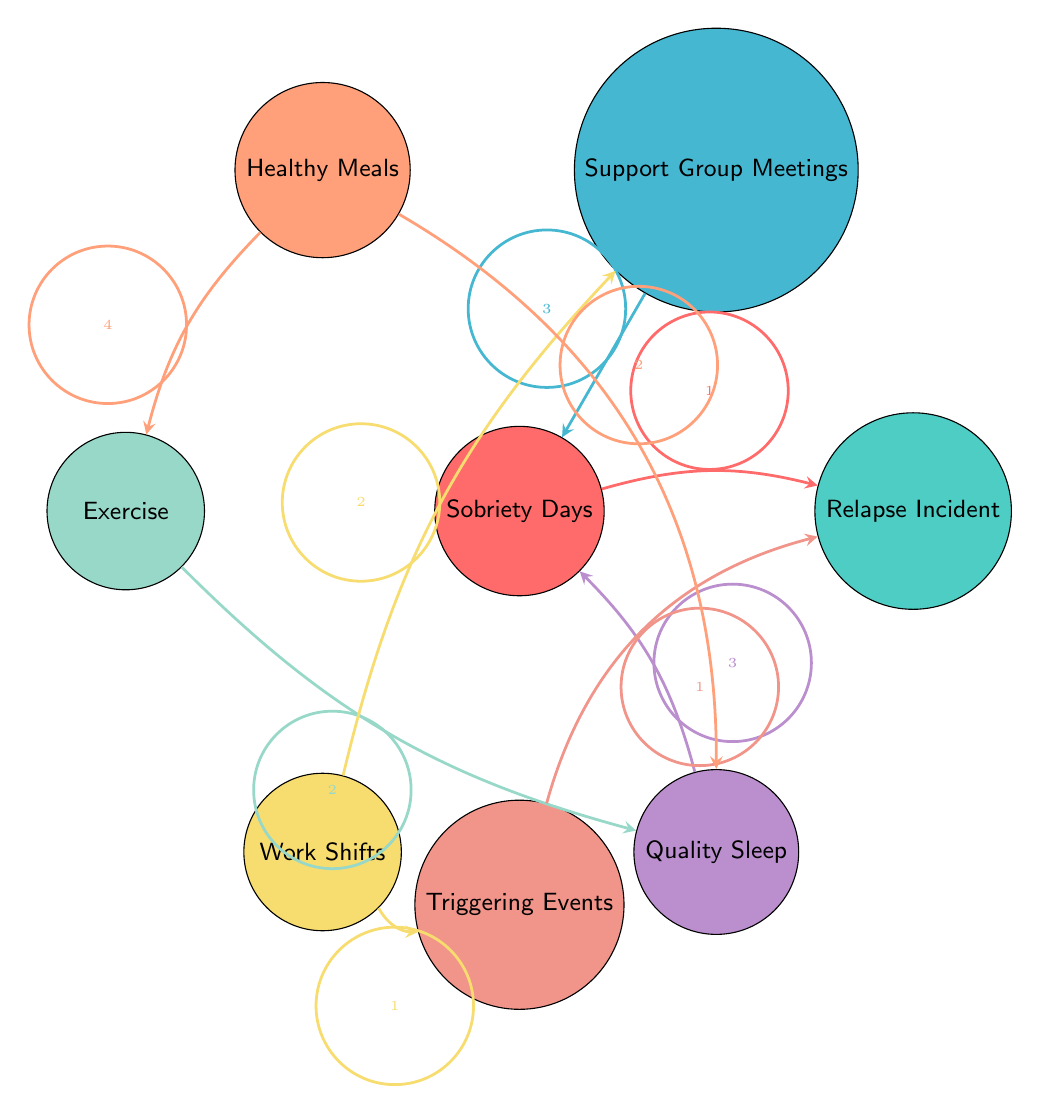What is the value of the link between Sobriety Days and Relapse Incident? The diagram shows a directed link from "Sobriety Days" to "Relapse Incident" with a value of 1. This indicates that there is one recorded incident related to the connection between these two nodes.
Answer: 1 How many nodes are present in the diagram? By counting the circles in the diagram, we identify eight nodes labeled: Sobriety Days, Relapse Incident, Support Group Meetings, Healthy Meals, Exercise, Work Shifts, Quality Sleep, and Triggering Events.
Answer: 8 What is the total value of links associated with Support Group Meetings? The diagram indicates a value of 3 links directed toward "Sobriety Days" and 2 links directed toward "Work Shifts", resulting in a total of 5 connections involving "Support Group Meetings".
Answer: 5 Which node has the highest total outgoing link value? By examining the outgoing links from each node, "Healthy Meals" has an outgoing link to "Exercise" with a value of 4 and to "Quality Sleep" with a value of 2. Therefore, its total outgoing links value of 6 is the highest.
Answer: Healthy Meals What is the relationship between Work Shifts and Triggering Events? The diagram shows a directed link from "Work Shifts" to "Triggering Events" with a value of 1, indicating that there is a singular connection indicating that work shifts contribute to triggering events.
Answer: 1 Which two nodes have the strongest connection based on the values of their links? The strongest connection is between "Support Group Meetings" and "Sobriety Days" with a link value of 3, making it the strongest relationship in the diagram when considering values.
Answer: Support Group Meetings and Sobriety Days How does Quality Sleep affect Sobriety Days in terms of link value? The diagram indicates a directed link from "Quality Sleep" to "Sobriety Days" with a value of 3. This shows that improved quality of sleep is positively associated with an increase in sobriety days.
Answer: 3 What triggers relapse incidents according to the diagram? The diagram shows that "Triggering Events" has a directed link to "Relapse Incident" with a value of 1, indicating a connection where certain events can trigger a relapse.
Answer: 1 What is the total number of links leading to Sobriety Days? "Sobriety Days" receives a total of 3 links from "Support Group Meetings" and 3 links from "Quality Sleep", totaling 6 links directed to it.
Answer: 6 